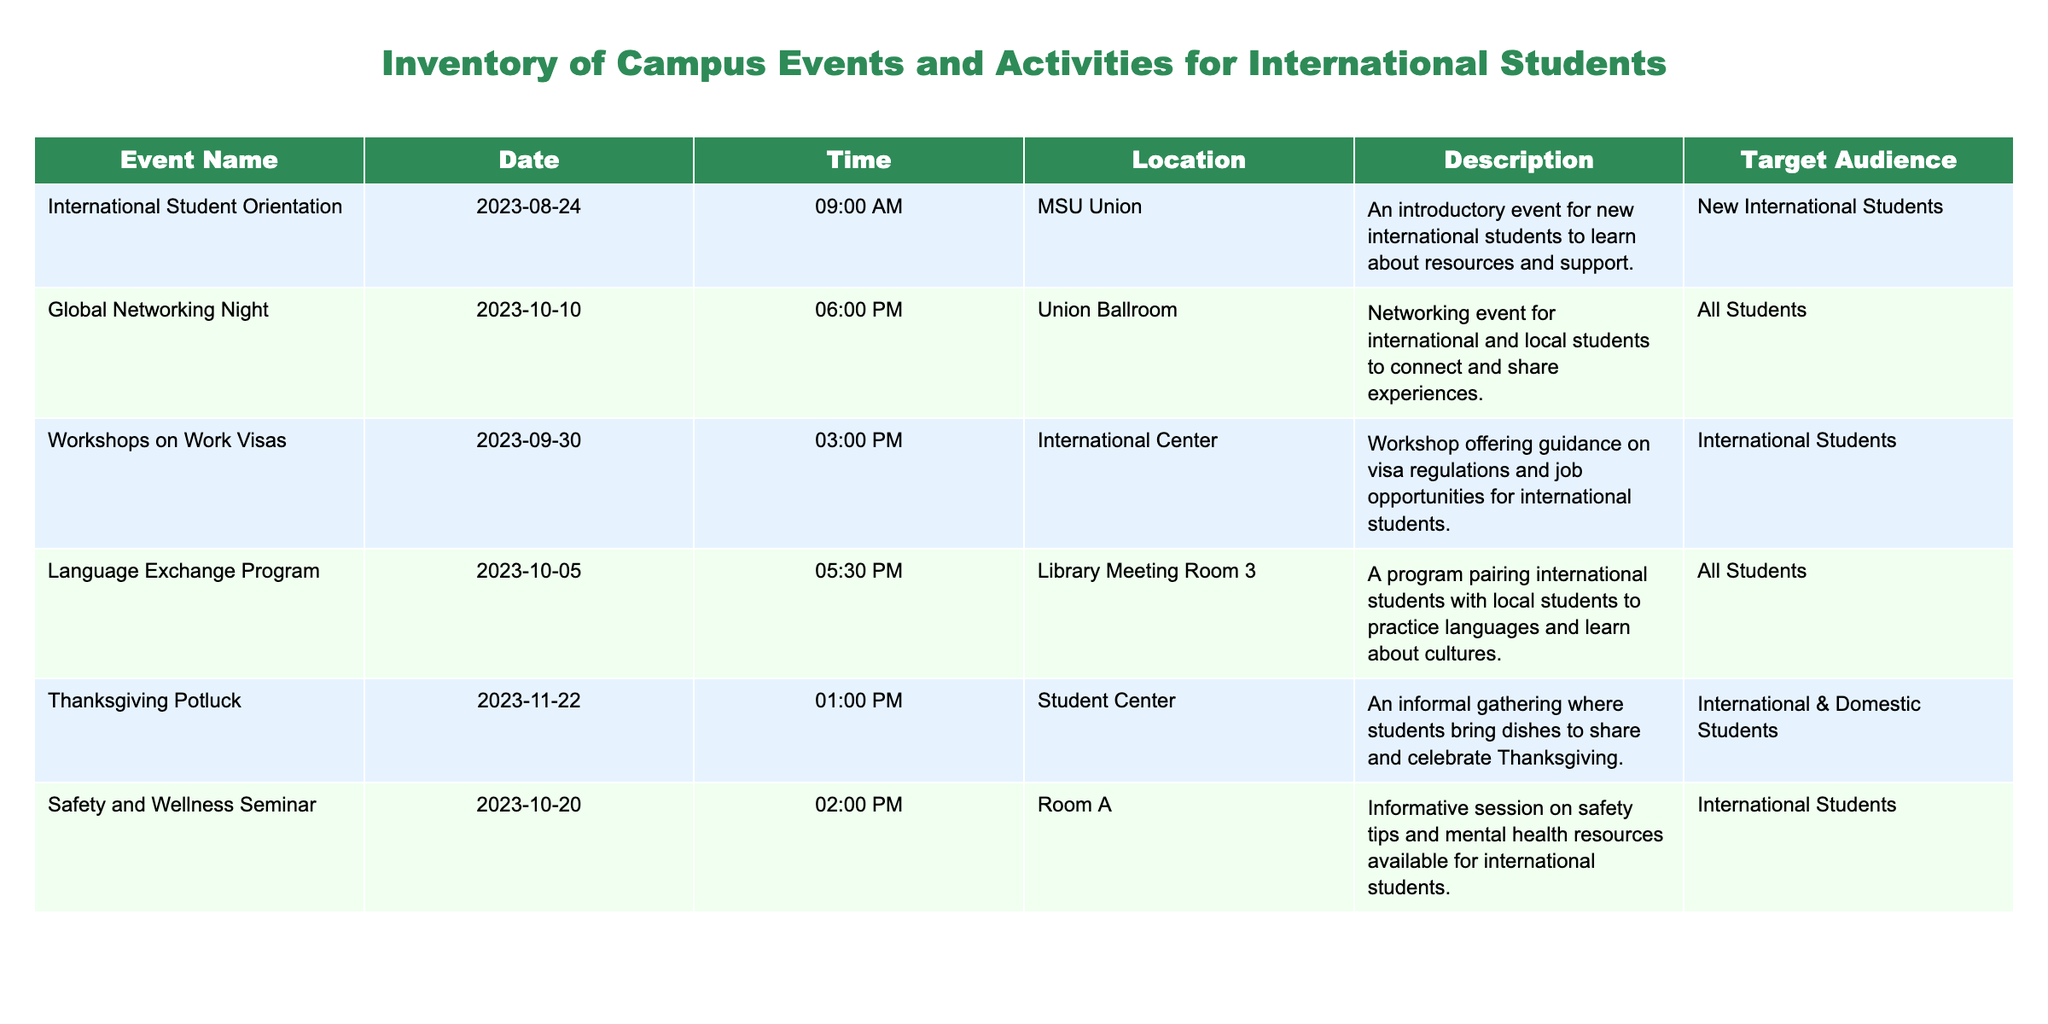What is the date of the International Student Orientation? The table lists the event name "International Student Orientation" along with its corresponding date, which is explicitly stated as "2023-08-24."
Answer: 2023-08-24 How many events are specifically targeted towards international students? By examining the target audience column, we identify the events aimed at international students: "International Student Orientation," "Workshops on Work Visas," "Safety and Wellness Seminar," and "Thanksgiving Potluck." This gives us a total of four events.
Answer: 4 Is the Global Networking Night designed for a specific group or is it open to everyone? The target audience for the "Global Networking Night" is mentioned as "All Students," indicating that it is open to everyone rather than a specific group.
Answer: Yes What is the earliest event listed in the table? To determine the earliest event, we must compare the dates of all events listed. The earliest date is "2023-08-24" for the "International Student Orientation."
Answer: International Student Orientation How many days are there between the Workshops on Work Visas and the Thanksgiving Potluck? The date of the Workshops on Work Visas is "2023-09-30" and the date of the Thanksgiving Potluck is "2023-11-22." Calculating the difference, there are 53 days between these two dates.
Answer: 53 days Which event occurs first in October? Comparing the two October events: "Global Networking Night" on "2023-10-10" and "Language Exchange Program" on "2023-10-05," it is clear that the Language Exchange Program occurs first.
Answer: Language Exchange Program Is there a safety and wellness seminar before or after the Language Exchange Program? The "Safety and Wellness Seminar" is scheduled for "2023-10-20," while the "Language Exchange Program" is on "2023-10-05." Since October 20 comes after October 5, the seminar is after the program.
Answer: After What percentage of the events are aimed at international students specifically? There are 6 total events listed; 4 of these events are targeted specifically at international students. To find the percentage, we calculate (4/6)*100, which equals approximately 66.67%.
Answer: 66.67% 